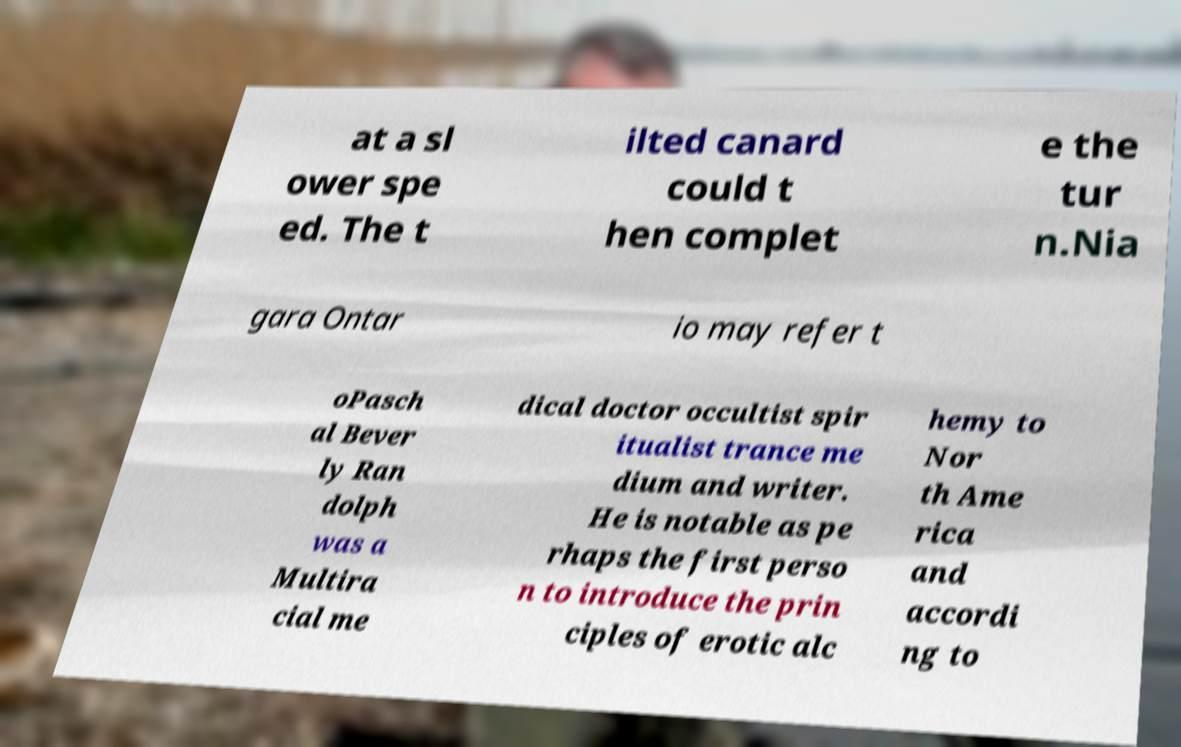For documentation purposes, I need the text within this image transcribed. Could you provide that? at a sl ower spe ed. The t ilted canard could t hen complet e the tur n.Nia gara Ontar io may refer t oPasch al Bever ly Ran dolph was a Multira cial me dical doctor occultist spir itualist trance me dium and writer. He is notable as pe rhaps the first perso n to introduce the prin ciples of erotic alc hemy to Nor th Ame rica and accordi ng to 